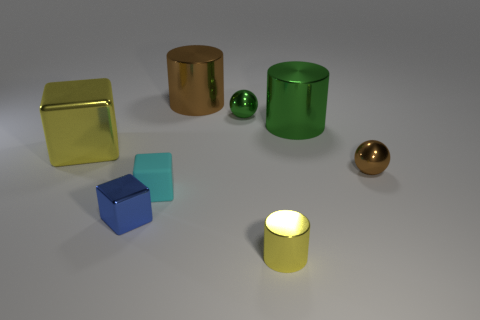There is a cylinder left of the yellow metallic thing in front of the blue thing; what is its size?
Offer a terse response. Large. Does the tiny metallic object that is left of the small cyan rubber object have the same shape as the small green object?
Provide a succinct answer. No. There is a large green object that is the same shape as the small yellow thing; what is its material?
Provide a short and direct response. Metal. What number of things are either large shiny things that are to the right of the tiny metallic block or tiny metallic objects to the right of the blue metal cube?
Ensure brevity in your answer.  5. Do the large shiny block and the metallic cylinder in front of the big yellow shiny block have the same color?
Ensure brevity in your answer.  Yes. The tiny brown thing that is the same material as the small cylinder is what shape?
Offer a terse response. Sphere. What number of tiny blocks are there?
Provide a succinct answer. 2. What number of objects are shiny objects that are to the right of the small blue block or rubber blocks?
Give a very brief answer. 6. There is a block behind the cyan matte block; does it have the same color as the tiny metal cylinder?
Provide a short and direct response. Yes. How many other things are there of the same color as the tiny cylinder?
Make the answer very short. 1. 